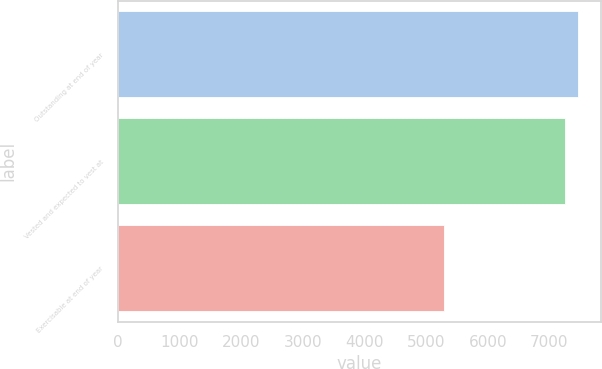<chart> <loc_0><loc_0><loc_500><loc_500><bar_chart><fcel>Outstanding at end of year<fcel>Vested and expected to vest at<fcel>Exercisable at end of year<nl><fcel>7463.7<fcel>7256<fcel>5298<nl></chart> 